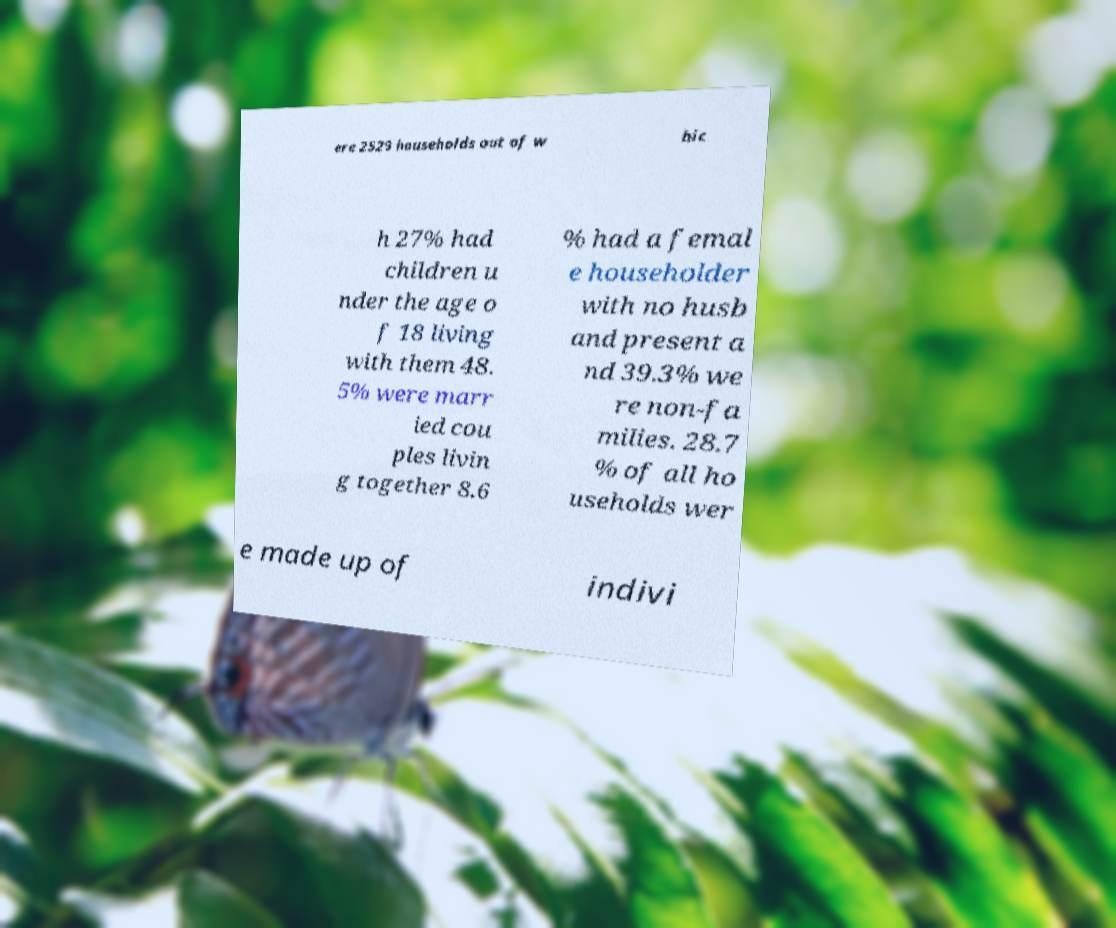Could you extract and type out the text from this image? ere 2529 households out of w hic h 27% had children u nder the age o f 18 living with them 48. 5% were marr ied cou ples livin g together 8.6 % had a femal e householder with no husb and present a nd 39.3% we re non-fa milies. 28.7 % of all ho useholds wer e made up of indivi 